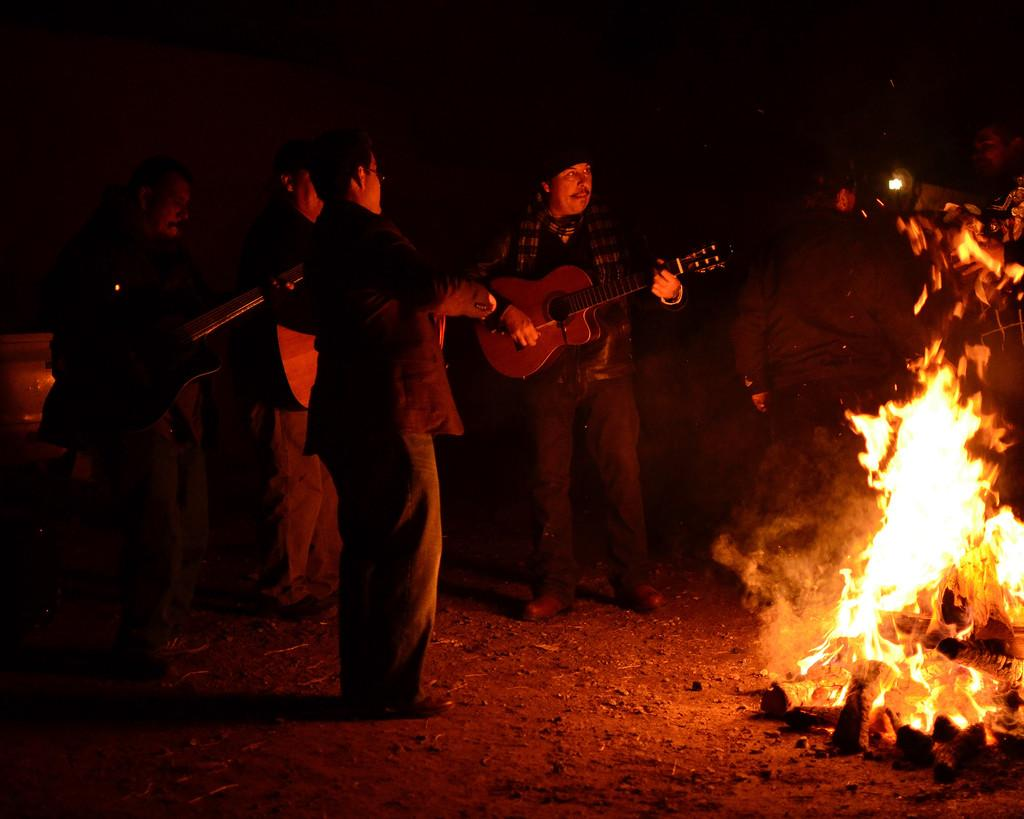What are the people in the image doing? There are people playing guitars in the image. What can be seen in the center of the image? There is a campfire in the image. What activity is happening in the background? In the background, there are people dancing. What type of canvas is being used to paint the nerve in the image? There is no canvas, nerve, or painting present in the image. How does the pull of the guitar strings affect the nerve in the image? There is no nerve or reference to a pull of guitar strings in the image. 